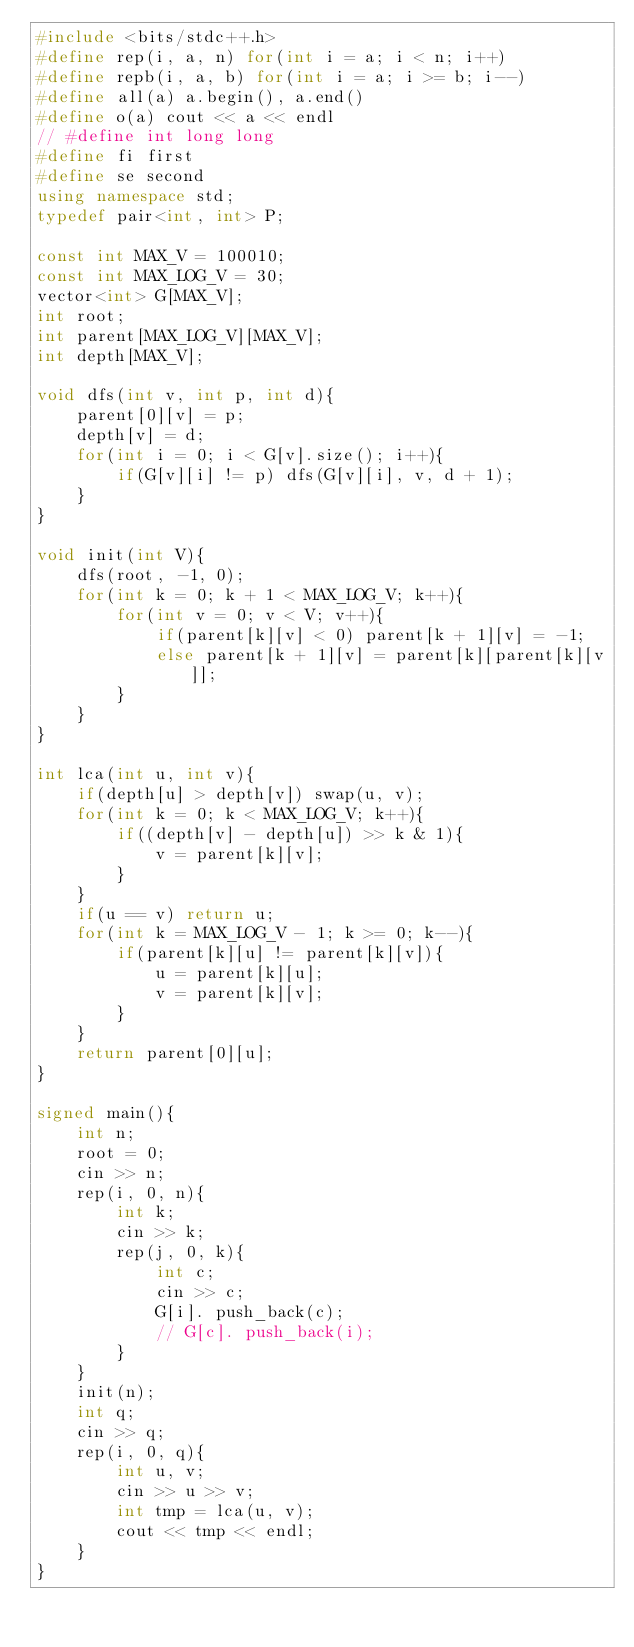Convert code to text. <code><loc_0><loc_0><loc_500><loc_500><_C++_>#include <bits/stdc++.h>
#define rep(i, a, n) for(int i = a; i < n; i++)
#define repb(i, a, b) for(int i = a; i >= b; i--)
#define all(a) a.begin(), a.end()
#define o(a) cout << a << endl
// #define int long long
#define fi first
#define se second
using namespace std;
typedef pair<int, int> P;

const int MAX_V = 100010;
const int MAX_LOG_V = 30;
vector<int> G[MAX_V];
int root;
int parent[MAX_LOG_V][MAX_V];
int depth[MAX_V];

void dfs(int v, int p, int d){
    parent[0][v] = p;
    depth[v] = d;
    for(int i = 0; i < G[v].size(); i++){
        if(G[v][i] != p) dfs(G[v][i], v, d + 1);
    }
}

void init(int V){
    dfs(root, -1, 0);
    for(int k = 0; k + 1 < MAX_LOG_V; k++){
        for(int v = 0; v < V; v++){
            if(parent[k][v] < 0) parent[k + 1][v] = -1;
            else parent[k + 1][v] = parent[k][parent[k][v]];
        }
    }
}

int lca(int u, int v){
    if(depth[u] > depth[v]) swap(u, v);
    for(int k = 0; k < MAX_LOG_V; k++){
        if((depth[v] - depth[u]) >> k & 1){
            v = parent[k][v];
        }
    }
    if(u == v) return u;
    for(int k = MAX_LOG_V - 1; k >= 0; k--){
        if(parent[k][u] != parent[k][v]){
            u = parent[k][u];
            v = parent[k][v];
        }
    }
    return parent[0][u];    
}

signed main(){
    int n;
    root = 0;
    cin >> n;
    rep(i, 0, n){
        int k;
        cin >> k;
        rep(j, 0, k){
            int c;
            cin >> c;
            G[i]. push_back(c);
            // G[c]. push_back(i);
        }
    }
    init(n);
    int q;
    cin >> q;
    rep(i, 0, q){
        int u, v;
        cin >> u >> v;
        int tmp = lca(u, v);
        cout << tmp << endl;
    }
}</code> 